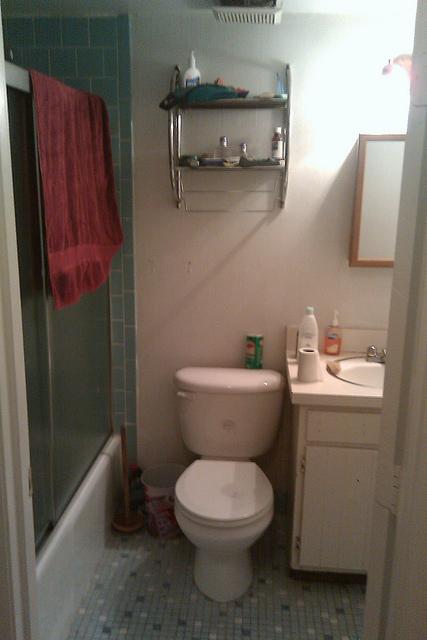Where is the toilet paper?
Keep it brief. On counter. What is hanging from pole?
Keep it brief. Towel. Is there any towels in this room?
Short answer required. Yes. What on top of the glass shelf above the toilet?
Keep it brief. Bottles. Is this bathroom small?
Write a very short answer. Yes. Is this a small bathroom?
Be succinct. Yes. 